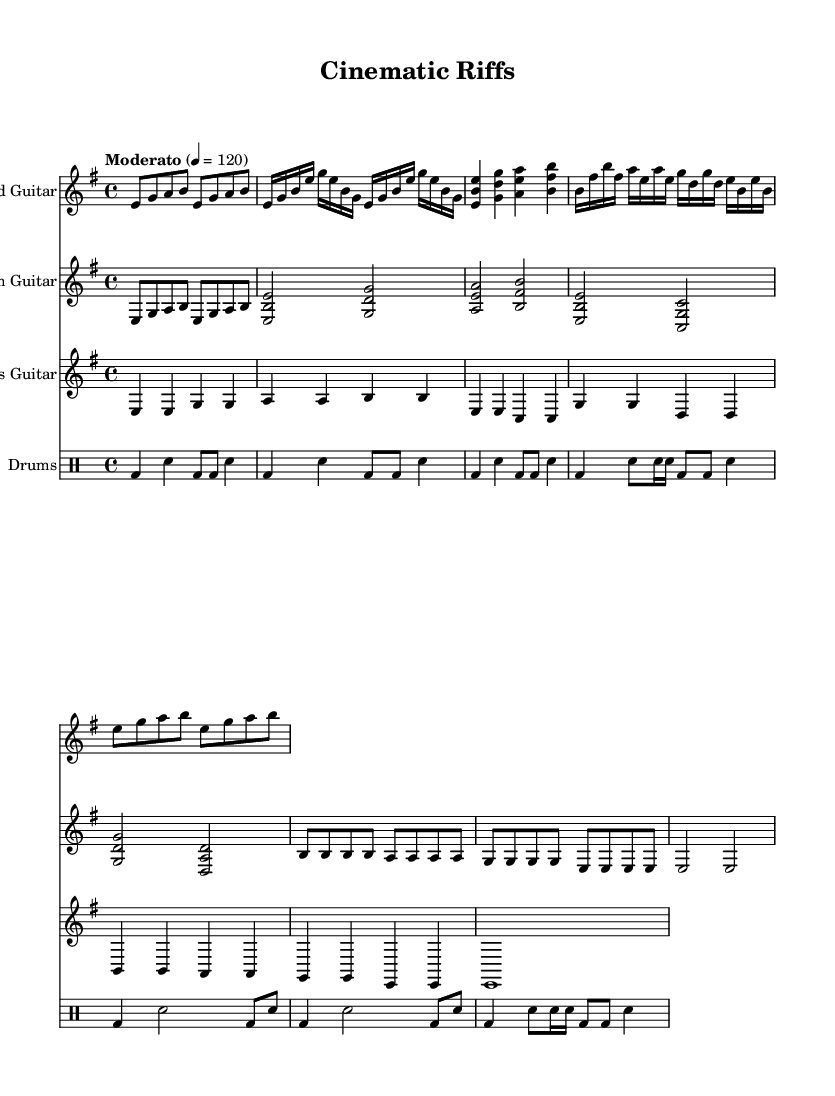What is the key signature of this music? The key signature is E minor, which has one sharp (F#). This can be determined by looking at the key signature indicated at the beginning of the sheet music.
Answer: E minor What is the time signature of this music? The time signature is 4/4, which is indicated in the beginning of the sheet music. This means there are four beats in a measure and the quarter note gets one beat.
Answer: 4/4 What is the tempo marking given in the music? The tempo marking is "Moderato," and it specifies a speed of 120 beats per minute. This is visible in the score where the tempo is notated as a directive to the musicians.
Answer: Moderato 120 Which instrument has the part labeled as "Lead Guitar"? The "Lead Guitar" is labeled and indicated in the sheet music, where it specifically identifies the staff that contains melodies played on the lead guitar.
Answer: Lead Guitar How many unique sections are indicated in the lead guitar part? The lead guitar part has five unique sections: Intro, Verse, Chorus, Bridge, and Outro. These sections can be identified by the distinct labels and musical content that varies throughout the piece.
Answer: Five What type of musical pattern is primarily used in the rhythm guitar? The rhythm guitar part predominantly features chord patterns, which are characterized by multiple notes being played together to create harmony. This can be seen in the way chords are grouped and played repeatedly.
Answer: Chord patterns What type of beat is established in the drums part? The drum part establishes a basic rock beat, which is characterized by a kick drum bass pattern combined with snare hits. This can be identified throughout the score where the bass drums and snares are consistently notated to create a driving rhythm.
Answer: Basic rock beat 